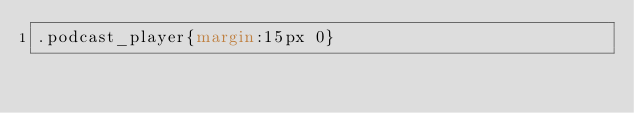Convert code to text. <code><loc_0><loc_0><loc_500><loc_500><_CSS_>.podcast_player{margin:15px 0}</code> 